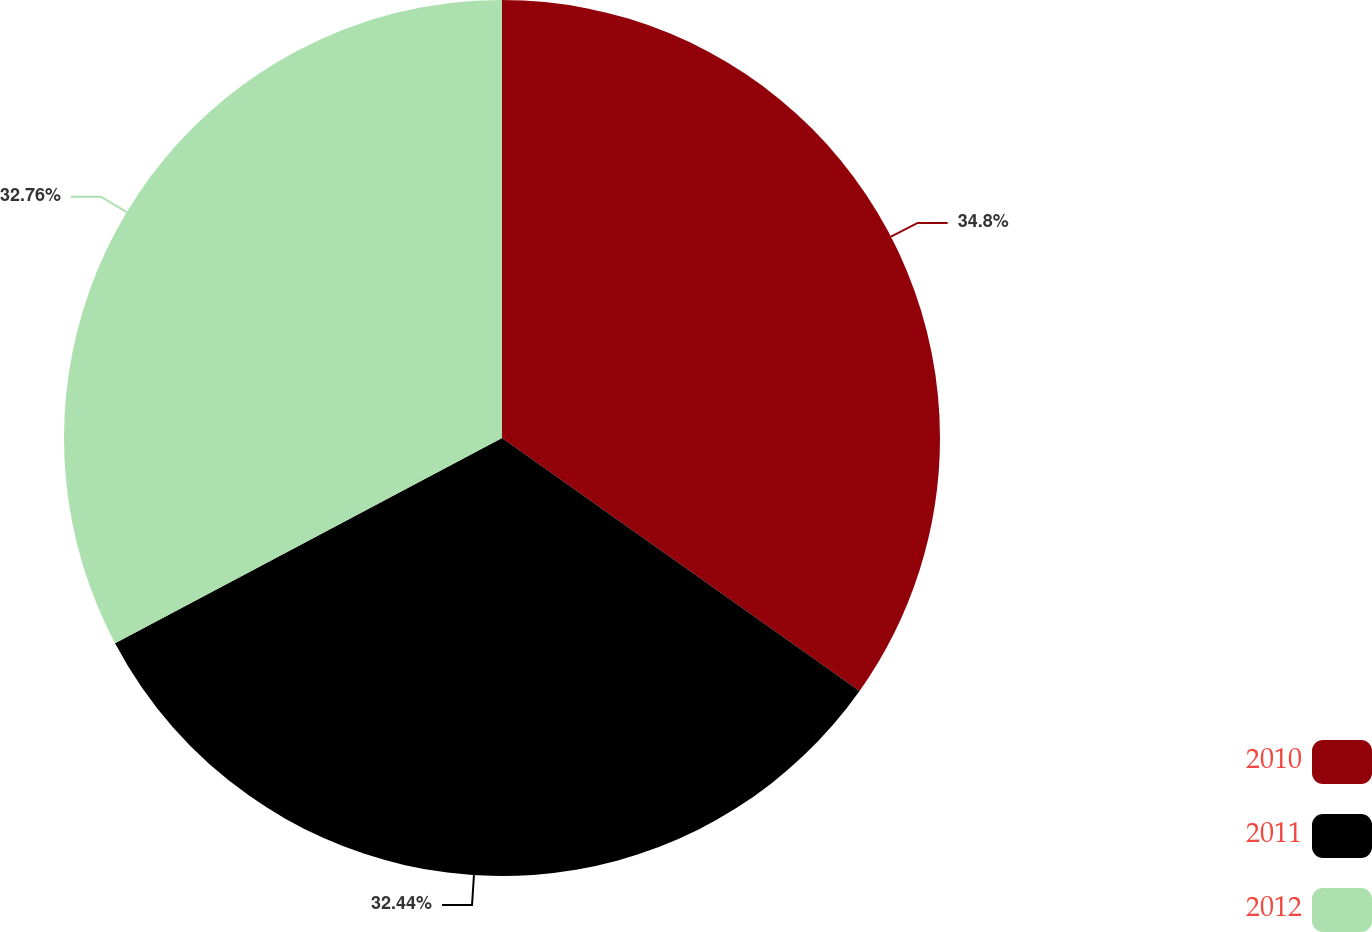<chart> <loc_0><loc_0><loc_500><loc_500><pie_chart><fcel>2010<fcel>2011<fcel>2012<nl><fcel>34.8%<fcel>32.44%<fcel>32.76%<nl></chart> 